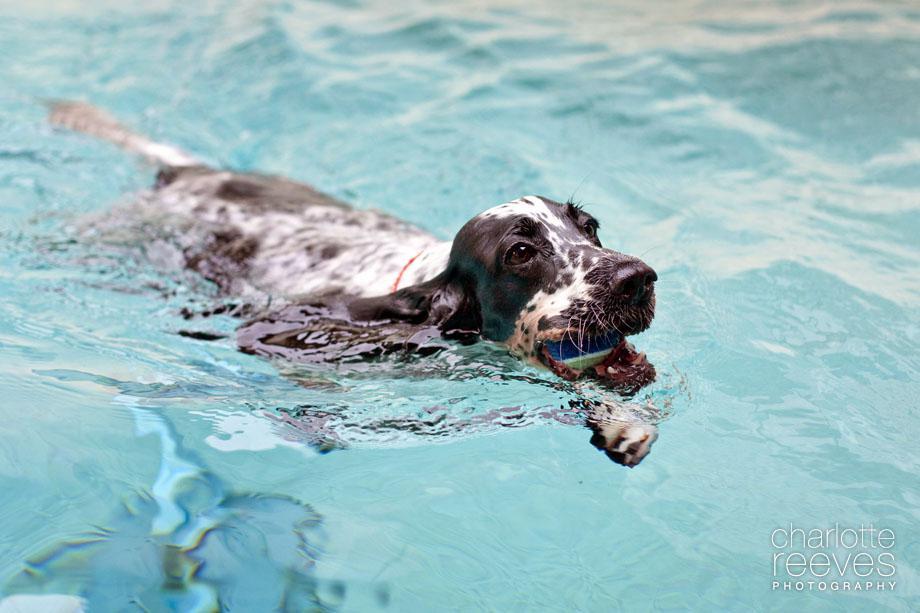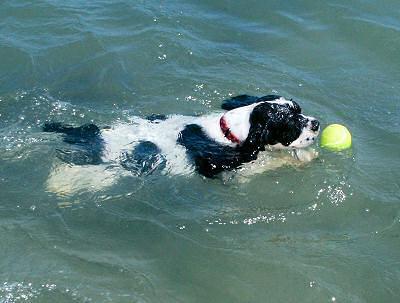The first image is the image on the left, the second image is the image on the right. Analyze the images presented: Is the assertion "The dog in the image on the right is standing in the water." valid? Answer yes or no. No. The first image is the image on the left, the second image is the image on the right. For the images shown, is this caption "An image shows a dog swimming leftward with a stick-shaped object in its mouth." true? Answer yes or no. No. 